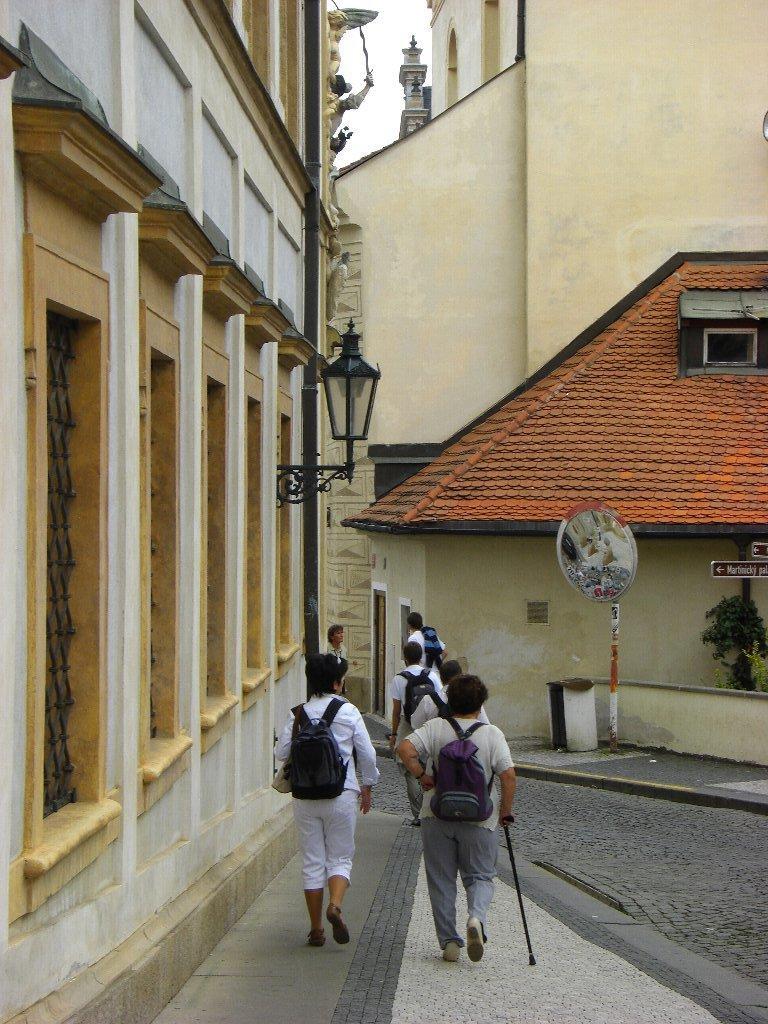Can you describe this image briefly? In this image we can see a group of people carrying bags are standing on the ground. One person is holding a stick in his hand. In the background, we can see a light pole, group of buildings with windows and the sky. 